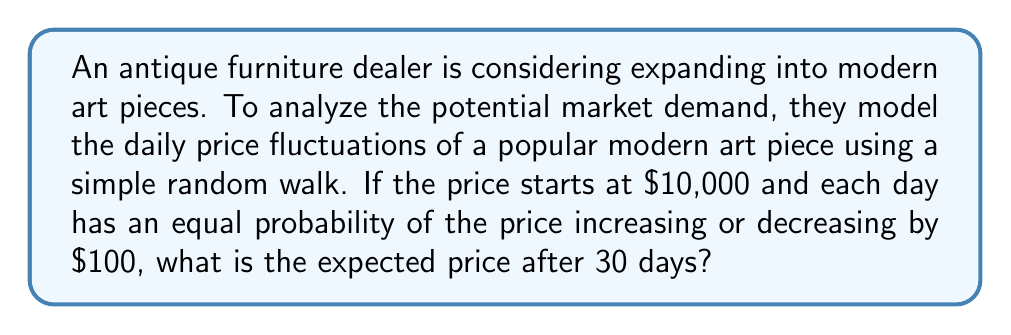Could you help me with this problem? Let's approach this step-by-step:

1) In a simple random walk model, the price changes are independent and identically distributed random variables.

2) Let $X_t$ represent the price on day $t$, and $\Delta X_t$ represent the daily change in price.

3) We're given:
   - $X_0 = 10000$ (initial price)
   - $P(\Delta X_t = 100) = P(\Delta X_t = -100) = 0.5$ for all $t$

4) The expected value of daily change is:
   $$E[\Delta X_t] = 100 \cdot 0.5 + (-100) \cdot 0.5 = 0$$

5) The expected price after $n$ days is given by:
   $$E[X_n] = X_0 + n \cdot E[\Delta X_t]$$

6) Substituting our values with $n = 30$:
   $$E[X_{30}] = 10000 + 30 \cdot 0 = 10000$$

Therefore, the expected price after 30 days remains $10,000.

This result is due to the symmetric nature of the random walk. While the actual price may fluctuate day-to-day, the expected value remains constant over time in this model.
Answer: $10,000 